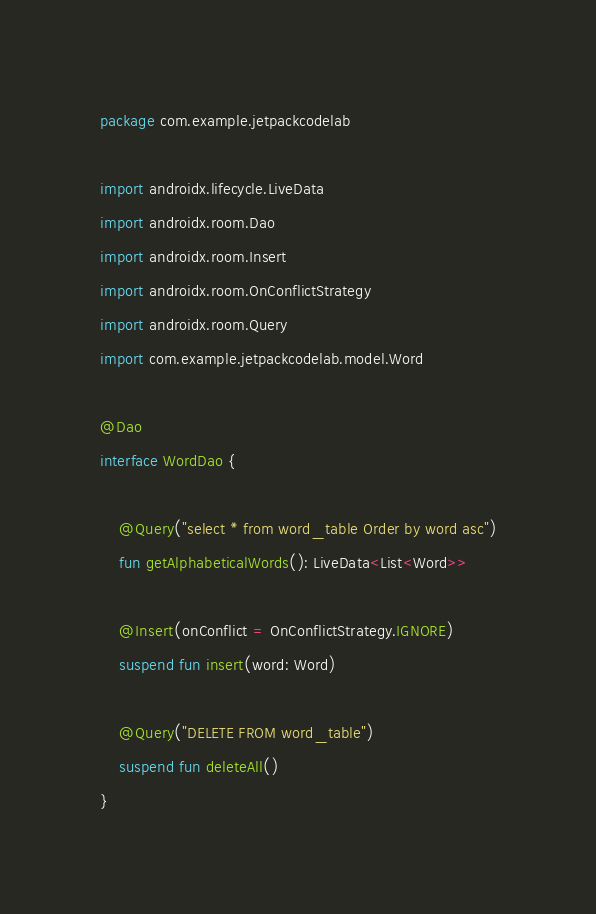Convert code to text. <code><loc_0><loc_0><loc_500><loc_500><_Kotlin_>package com.example.jetpackcodelab

import androidx.lifecycle.LiveData
import androidx.room.Dao
import androidx.room.Insert
import androidx.room.OnConflictStrategy
import androidx.room.Query
import com.example.jetpackcodelab.model.Word

@Dao
interface WordDao {

    @Query("select * from word_table Order by word asc")
    fun getAlphabeticalWords(): LiveData<List<Word>>

    @Insert(onConflict = OnConflictStrategy.IGNORE)
    suspend fun insert(word: Word)

    @Query("DELETE FROM word_table")
    suspend fun deleteAll()
}</code> 